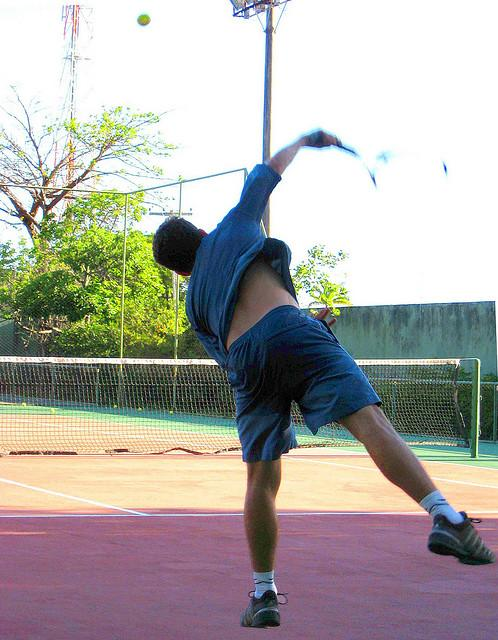What move has the player just used? Please explain your reasoning. serve. When serving in tennis, the player swings higher up into the air to shoot the ball really fast. 